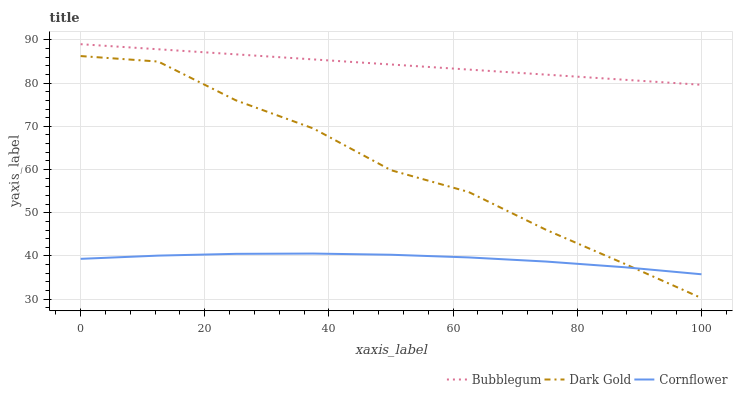Does Cornflower have the minimum area under the curve?
Answer yes or no. Yes. Does Bubblegum have the maximum area under the curve?
Answer yes or no. Yes. Does Dark Gold have the minimum area under the curve?
Answer yes or no. No. Does Dark Gold have the maximum area under the curve?
Answer yes or no. No. Is Bubblegum the smoothest?
Answer yes or no. Yes. Is Dark Gold the roughest?
Answer yes or no. Yes. Is Dark Gold the smoothest?
Answer yes or no. No. Is Bubblegum the roughest?
Answer yes or no. No. Does Dark Gold have the lowest value?
Answer yes or no. Yes. Does Bubblegum have the lowest value?
Answer yes or no. No. Does Bubblegum have the highest value?
Answer yes or no. Yes. Does Dark Gold have the highest value?
Answer yes or no. No. Is Dark Gold less than Bubblegum?
Answer yes or no. Yes. Is Bubblegum greater than Dark Gold?
Answer yes or no. Yes. Does Dark Gold intersect Cornflower?
Answer yes or no. Yes. Is Dark Gold less than Cornflower?
Answer yes or no. No. Is Dark Gold greater than Cornflower?
Answer yes or no. No. Does Dark Gold intersect Bubblegum?
Answer yes or no. No. 